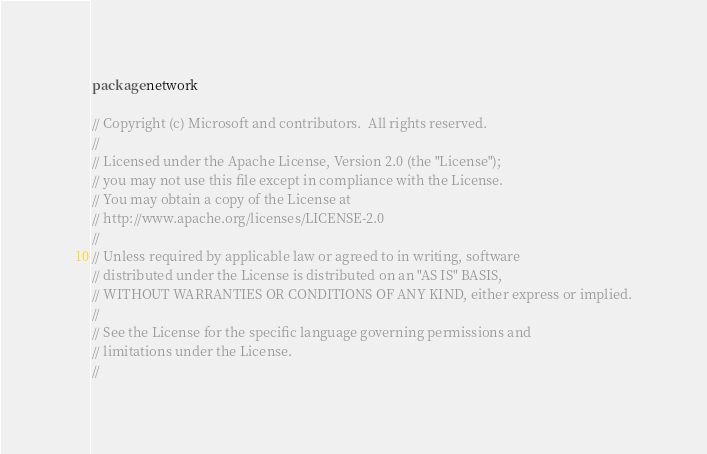Convert code to text. <code><loc_0><loc_0><loc_500><loc_500><_Go_>package network

// Copyright (c) Microsoft and contributors.  All rights reserved.
//
// Licensed under the Apache License, Version 2.0 (the "License");
// you may not use this file except in compliance with the License.
// You may obtain a copy of the License at
// http://www.apache.org/licenses/LICENSE-2.0
//
// Unless required by applicable law or agreed to in writing, software
// distributed under the License is distributed on an "AS IS" BASIS,
// WITHOUT WARRANTIES OR CONDITIONS OF ANY KIND, either express or implied.
//
// See the License for the specific language governing permissions and
// limitations under the License.
//</code> 